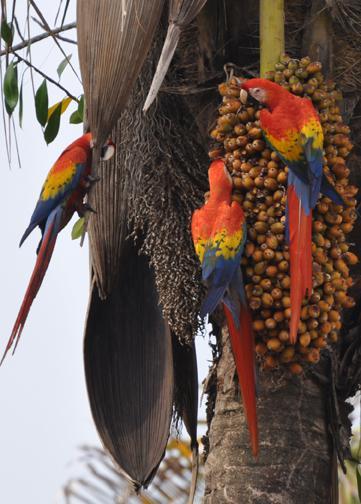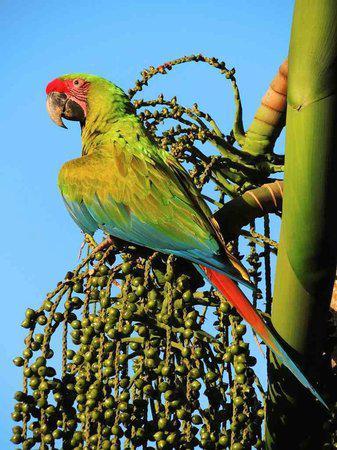The first image is the image on the left, the second image is the image on the right. For the images shown, is this caption "There are exactly two birds in total." true? Answer yes or no. No. The first image is the image on the left, the second image is the image on the right. Given the left and right images, does the statement "There are two parrots." hold true? Answer yes or no. No. 